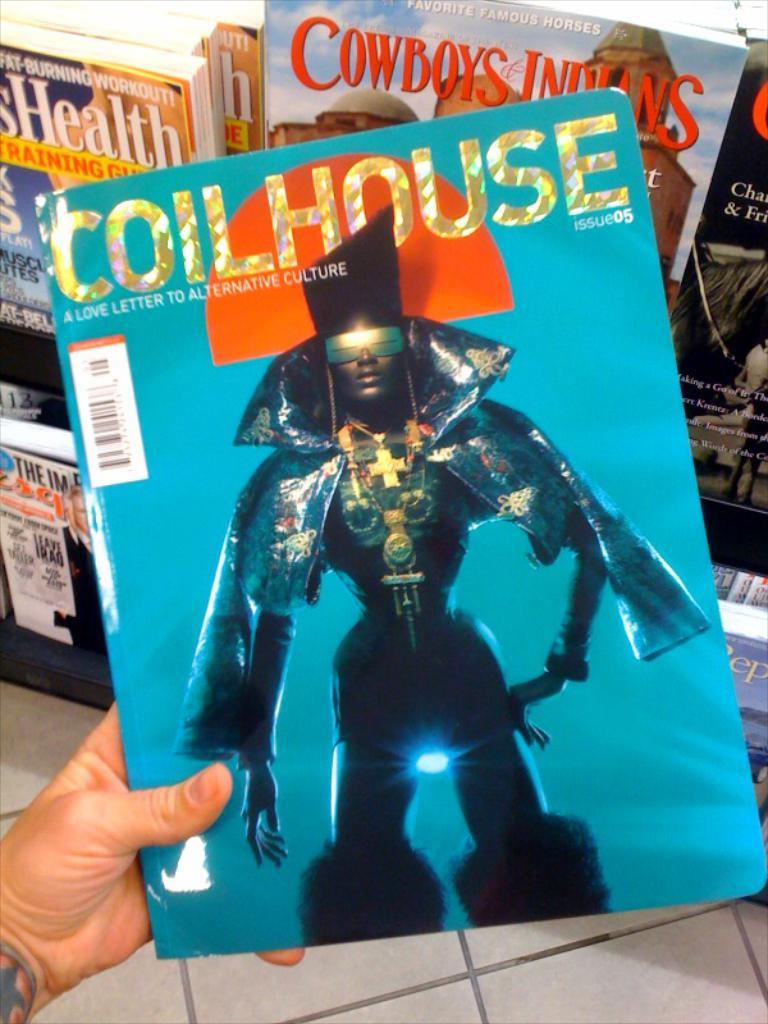<image>
Create a compact narrative representing the image presented. A copy of Coilhouse magazine with a person dressed up fashionably on the front. 